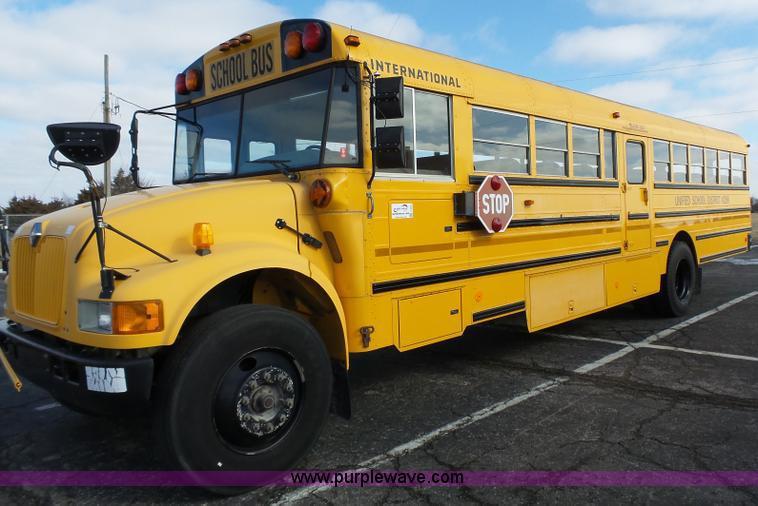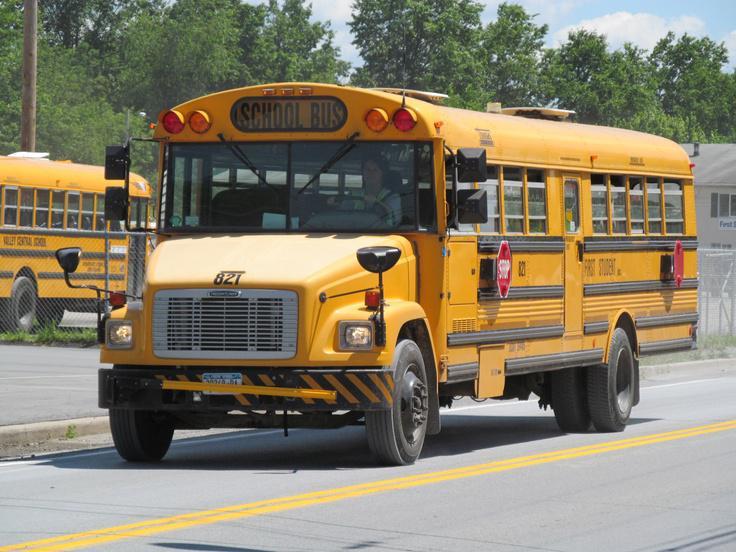The first image is the image on the left, the second image is the image on the right. Examine the images to the left and right. Is the description "Exactly one bus stop sign is visible." accurate? Answer yes or no. No. 